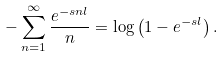<formula> <loc_0><loc_0><loc_500><loc_500>- \sum _ { n = 1 } ^ { \infty } \frac { e ^ { - s n l } } n = \log \left ( 1 - e ^ { - s l } \right ) .</formula> 